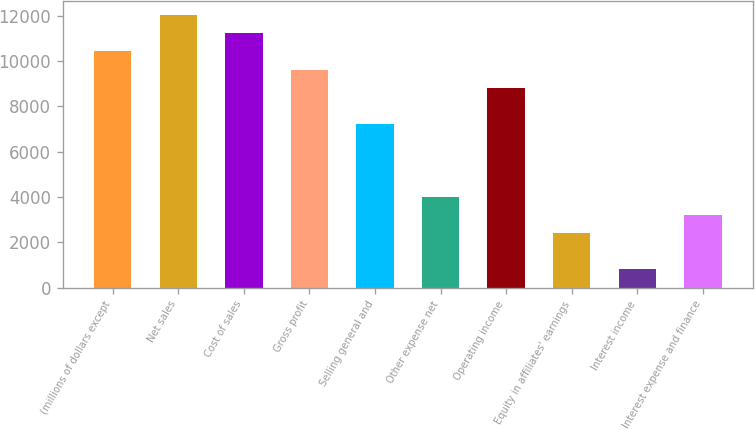Convert chart to OTSL. <chart><loc_0><loc_0><loc_500><loc_500><bar_chart><fcel>(millions of dollars except<fcel>Net sales<fcel>Cost of sales<fcel>Gross profit<fcel>Selling general and<fcel>Other expense net<fcel>Operating income<fcel>Equity in affiliates' earnings<fcel>Interest income<fcel>Interest expense and finance<nl><fcel>10429.4<fcel>12033.5<fcel>11231.4<fcel>9627.3<fcel>7221.15<fcel>4012.95<fcel>8825.25<fcel>2408.85<fcel>804.75<fcel>3210.9<nl></chart> 